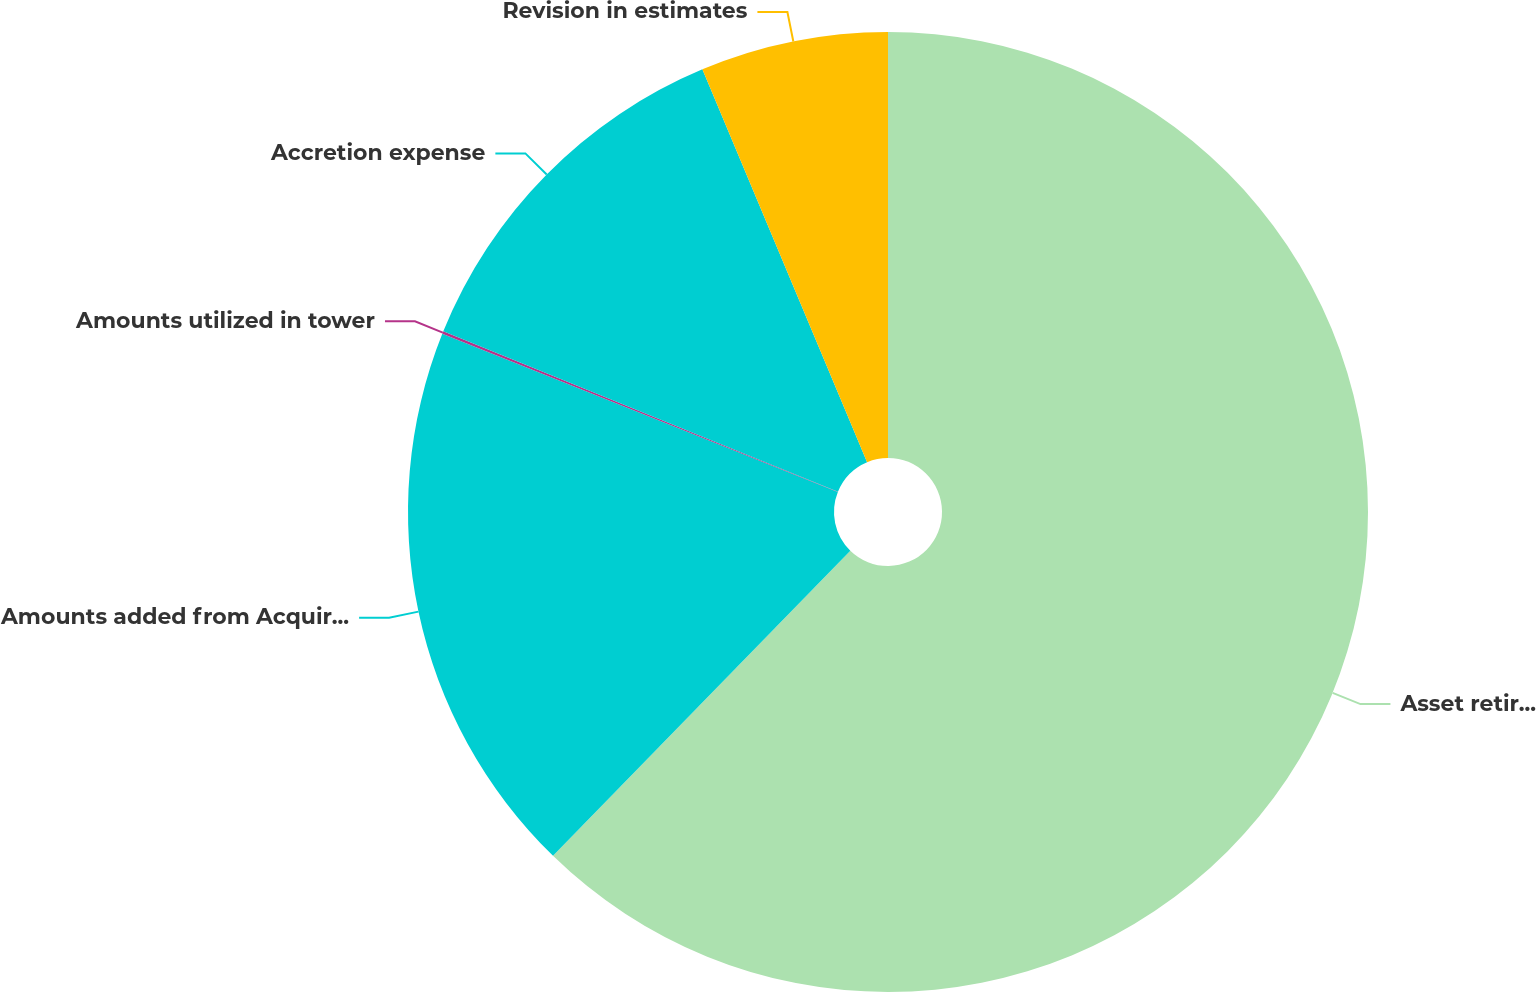Convert chart to OTSL. <chart><loc_0><loc_0><loc_500><loc_500><pie_chart><fcel>Asset retirement obligation at<fcel>Amounts added from Acquired<fcel>Amounts utilized in tower<fcel>Accretion expense<fcel>Revision in estimates<nl><fcel>62.3%<fcel>18.76%<fcel>0.09%<fcel>12.54%<fcel>6.32%<nl></chart> 